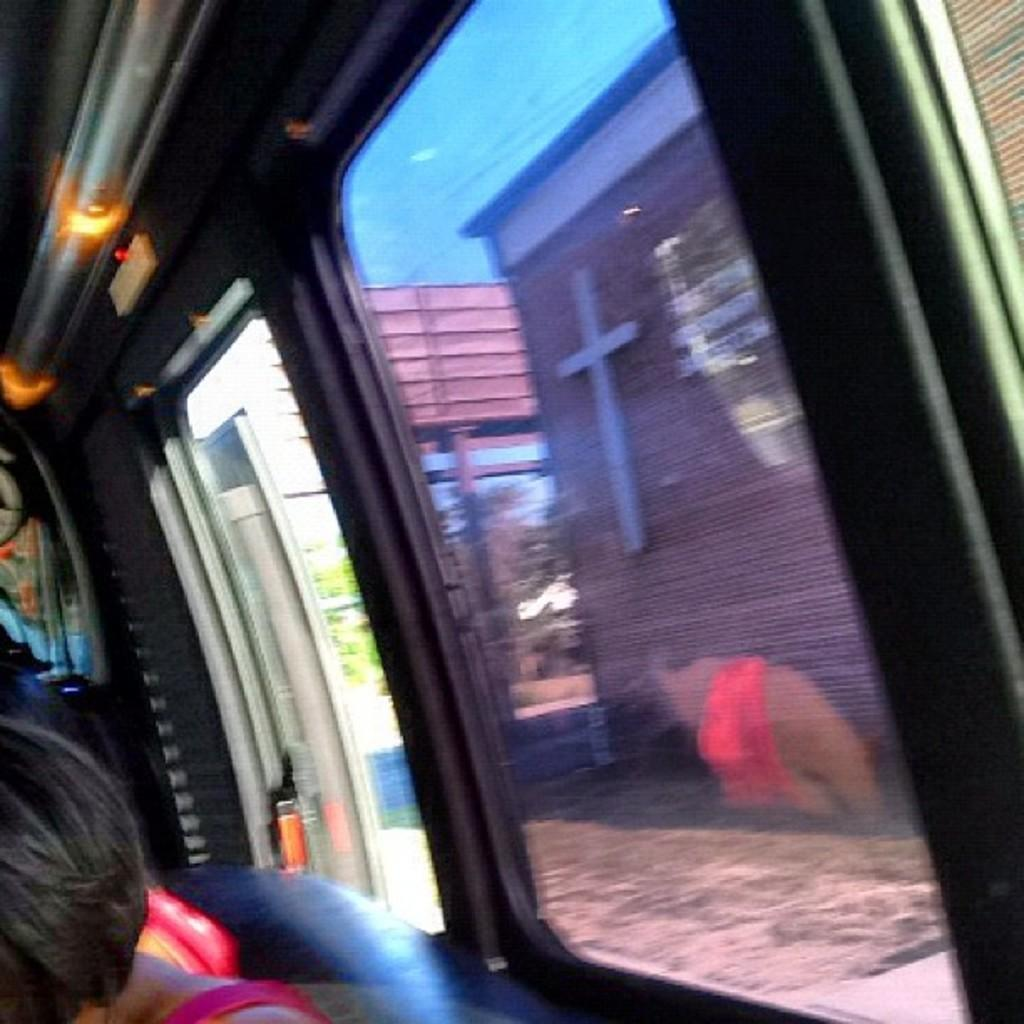Where was the image taken? The image was taken inside a bus. What can be seen at the bottom of the image? There are people sitting at the bottom of the image. What is present on the right side of the image? There are windows on the right side of the image. What can be seen through the windows? Buildings are visible through the windows. What type of advice can be heard being given in the image? There is no conversation or dialogue present in the image, so it is not possible to determine what advice might be given. 